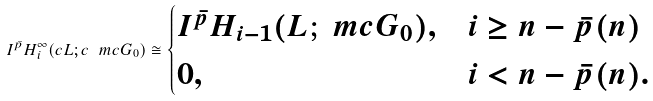Convert formula to latex. <formula><loc_0><loc_0><loc_500><loc_500>I ^ { \bar { p } } H ^ { \infty } _ { i } ( c L ; c \ m c G _ { 0 } ) \cong \begin{cases} I ^ { \bar { p } } H _ { i - 1 } ( L ; \ m c G _ { 0 } ) , & i \geq n - \bar { p } ( n ) \\ 0 , & i < n - \bar { p } ( n ) . \end{cases}</formula> 